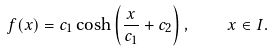Convert formula to latex. <formula><loc_0><loc_0><loc_500><loc_500>f ( x ) = c _ { 1 } \cosh \left ( \frac { x } { c _ { 1 } } + c _ { 2 } \right ) , \quad x \in I .</formula> 